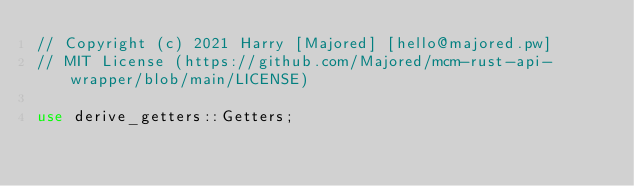<code> <loc_0><loc_0><loc_500><loc_500><_Rust_>// Copyright (c) 2021 Harry [Majored] [hello@majored.pw]
// MIT License (https://github.com/Majored/mcm-rust-api-wrapper/blob/main/LICENSE)

use derive_getters::Getters;</code> 